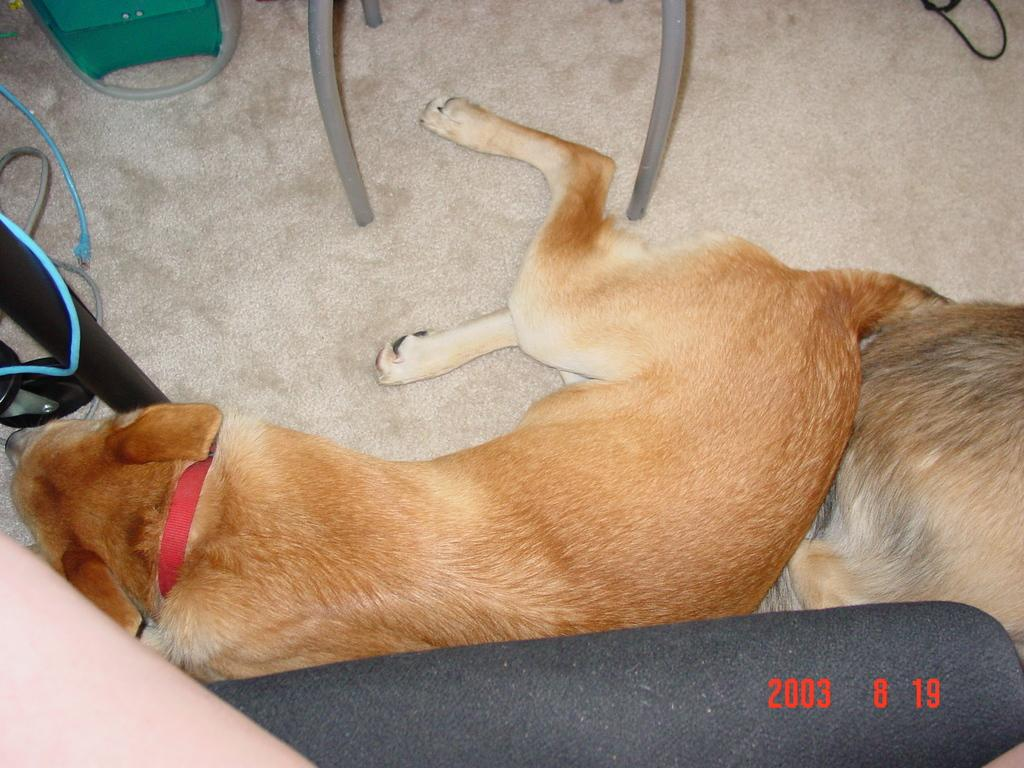What type of animal can be seen in the image? There is a brown color dog in the image. What is the dog doing in the image? The dog is sitting on the floor. Can you describe another animal in the image? There is another animal sitting in the image. What type of furniture is present in the image? There is a chair in the image. What color is the green object in the image? There is a green color object in the image. What type of current is flowing through the faucet in the image? There is no faucet present in the image, so it is not possible to determine the type of current flowing through it. 